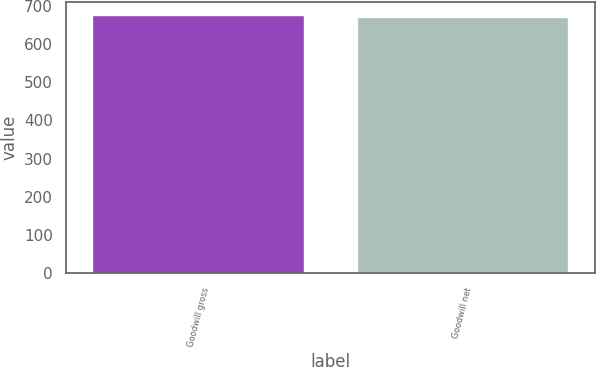Convert chart to OTSL. <chart><loc_0><loc_0><loc_500><loc_500><bar_chart><fcel>Goodwill gross<fcel>Goodwill net<nl><fcel>677<fcel>672<nl></chart> 